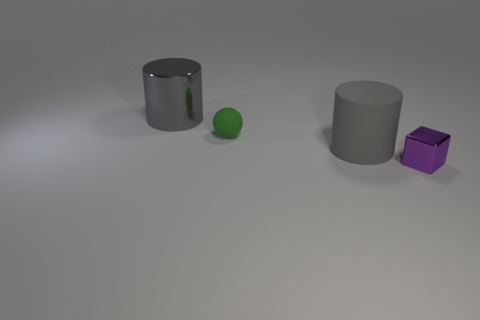Subtract all cubes. How many objects are left? 3 Add 2 cyan matte cylinders. How many objects exist? 6 Subtract 0 purple cylinders. How many objects are left? 4 Subtract all green cubes. Subtract all yellow cylinders. How many cubes are left? 1 Subtract all large yellow things. Subtract all purple things. How many objects are left? 3 Add 1 purple cubes. How many purple cubes are left? 2 Add 1 big green matte spheres. How many big green matte spheres exist? 1 